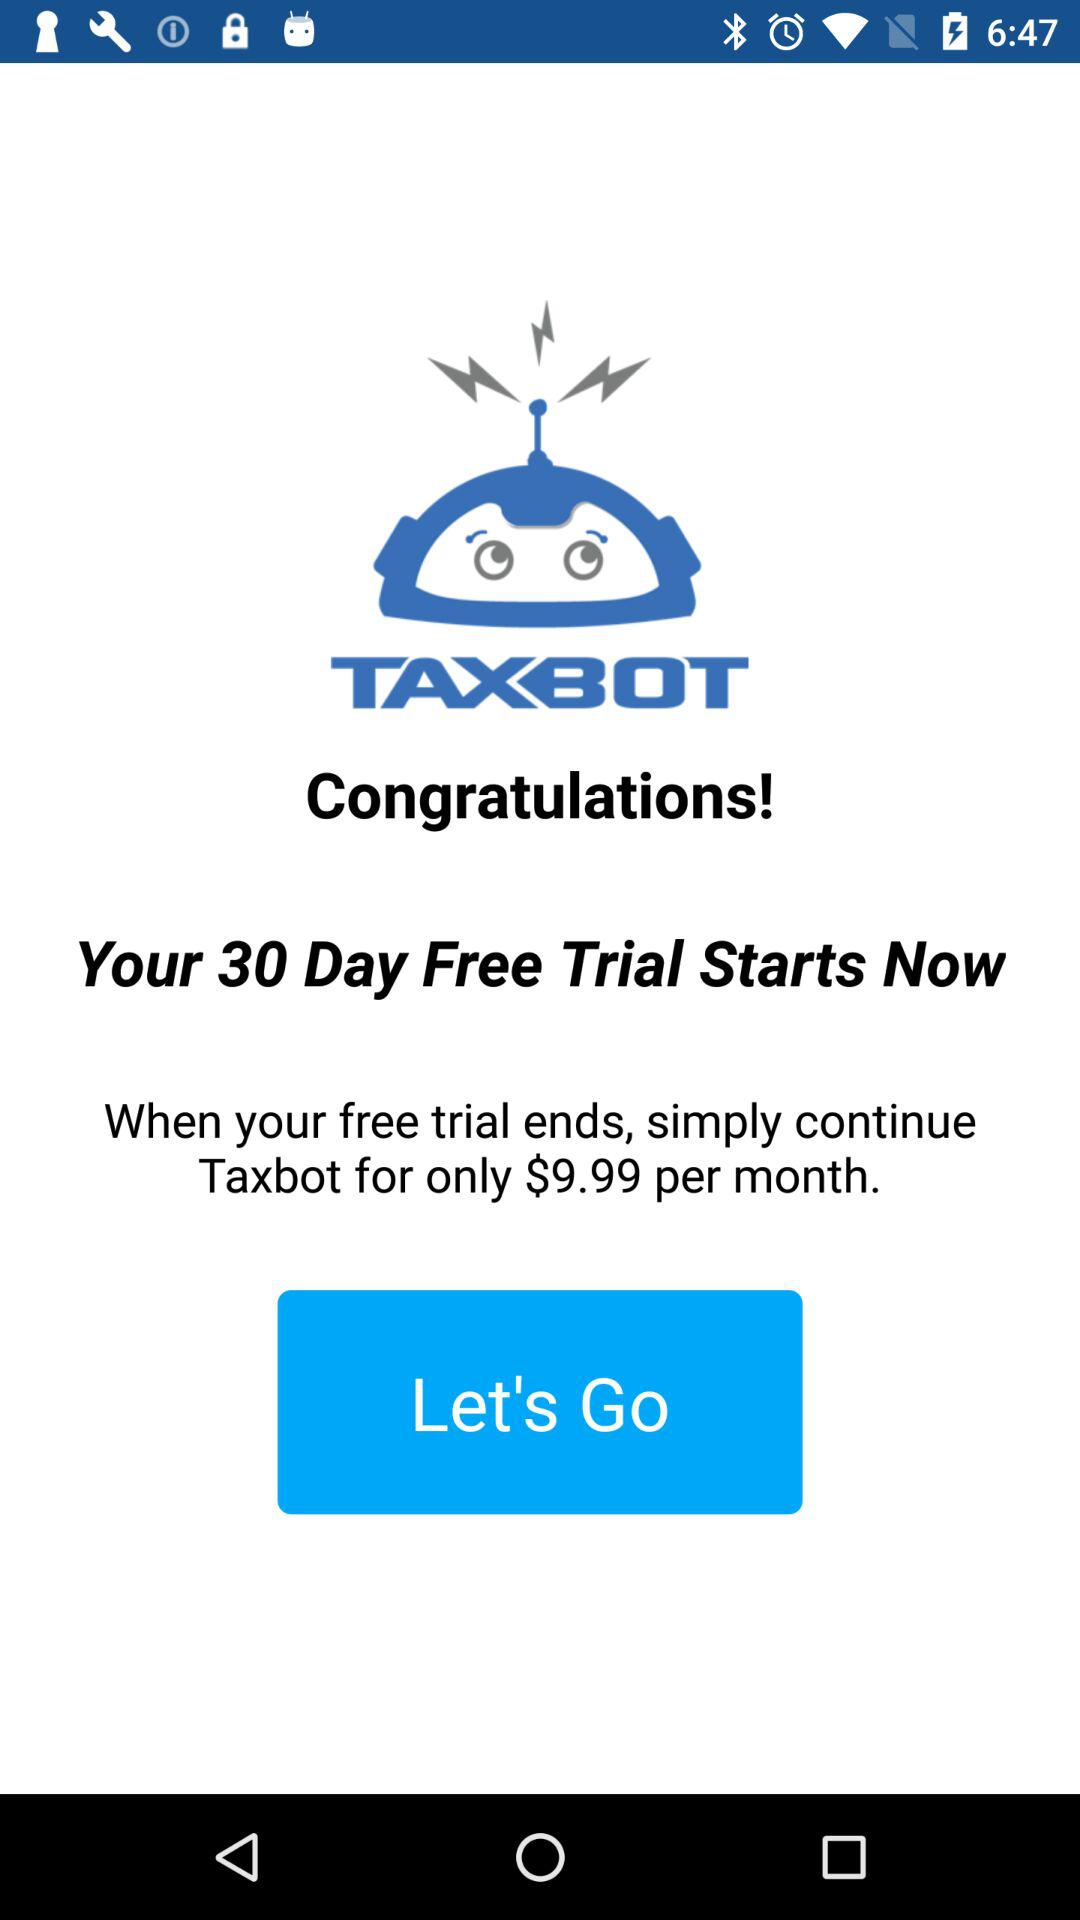What's the price of "Taxbot" per month? The price of "Taxbot" per month is $9.99. 